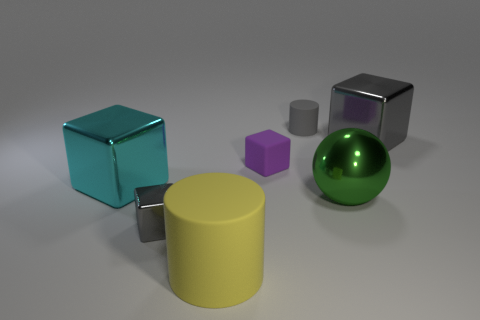Is the material of the block that is right of the sphere the same as the green ball?
Your answer should be very brief. Yes. There is a big metal thing behind the cyan cube; what shape is it?
Provide a succinct answer. Cube. What number of cubes are the same size as the gray matte cylinder?
Your answer should be compact. 2. What size is the cyan object?
Keep it short and to the point. Large. What number of big green spheres are on the left side of the small matte cylinder?
Your answer should be compact. 0. What shape is the green thing that is made of the same material as the big gray cube?
Offer a very short reply. Sphere. Are there fewer big green metallic balls in front of the small rubber cube than big yellow matte things right of the large yellow cylinder?
Ensure brevity in your answer.  No. Is the number of big purple things greater than the number of spheres?
Make the answer very short. No. What is the large yellow cylinder made of?
Provide a succinct answer. Rubber. There is a large object to the left of the tiny metallic object; what color is it?
Ensure brevity in your answer.  Cyan. 